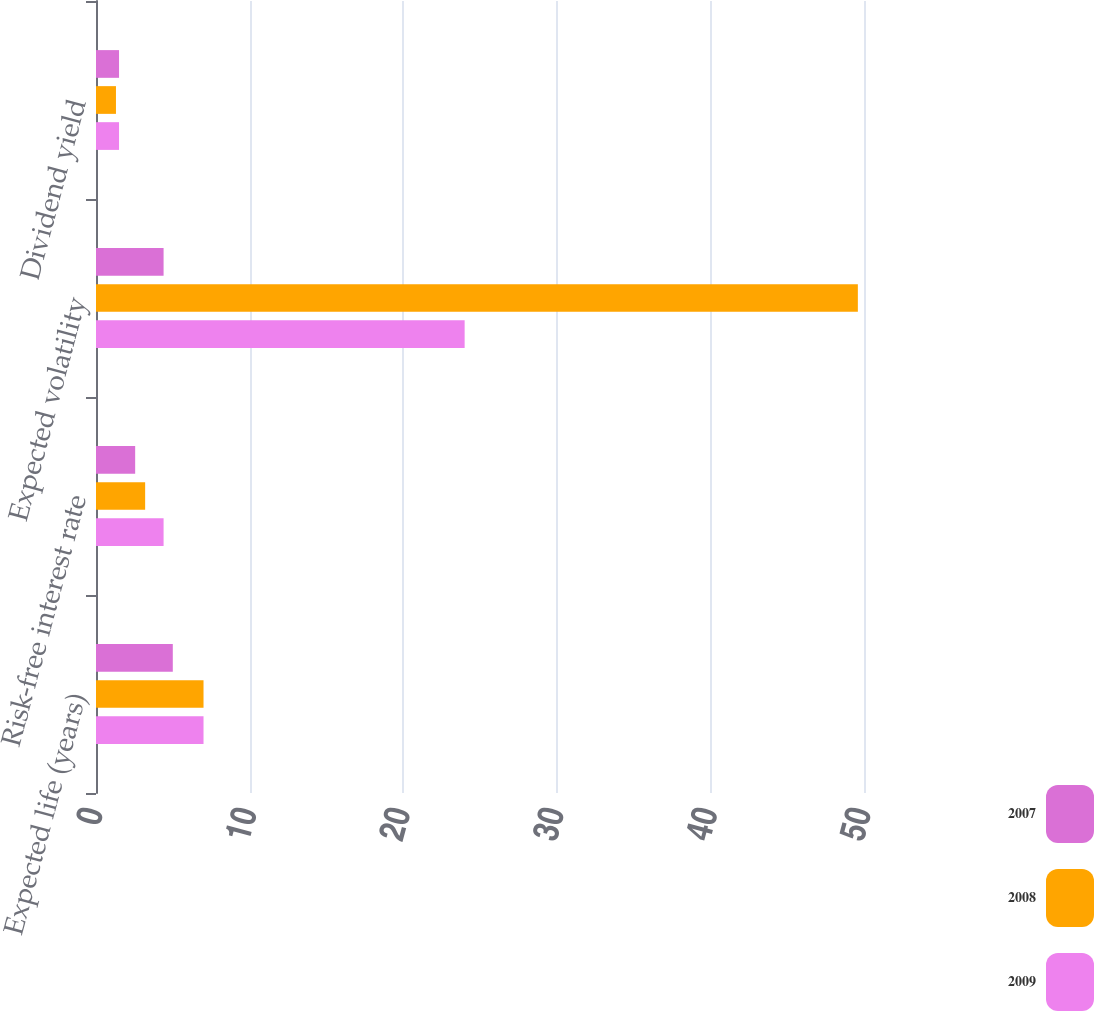<chart> <loc_0><loc_0><loc_500><loc_500><stacked_bar_chart><ecel><fcel>Expected life (years)<fcel>Risk-free interest rate<fcel>Expected volatility<fcel>Dividend yield<nl><fcel>2007<fcel>5<fcel>2.55<fcel>4.4<fcel>1.5<nl><fcel>2008<fcel>7<fcel>3.2<fcel>49.6<fcel>1.3<nl><fcel>2009<fcel>7<fcel>4.4<fcel>24<fcel>1.5<nl></chart> 